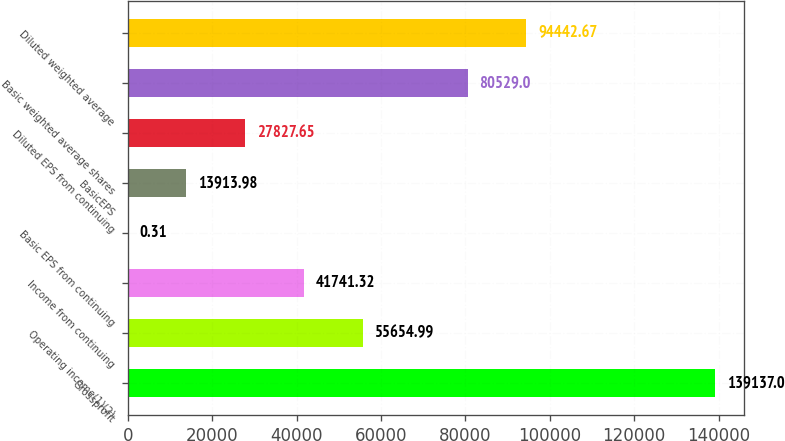Convert chart to OTSL. <chart><loc_0><loc_0><loc_500><loc_500><bar_chart><fcel>Grossprofit<fcel>Operating income(1)(2)<fcel>Income from continuing<fcel>Basic EPS from continuing<fcel>BasicEPS<fcel>Diluted EPS from continuing<fcel>Basic weighted average shares<fcel>Diluted weighted average<nl><fcel>139137<fcel>55655<fcel>41741.3<fcel>0.31<fcel>13914<fcel>27827.7<fcel>80529<fcel>94442.7<nl></chart> 